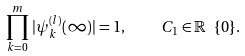Convert formula to latex. <formula><loc_0><loc_0><loc_500><loc_500>\prod _ { k = 0 } ^ { m } \, | \psi ^ { ( l ) } _ { k } ( \infty ) | = 1 , \quad C _ { 1 } \in \mathbb { R } \ \{ 0 \} .</formula> 